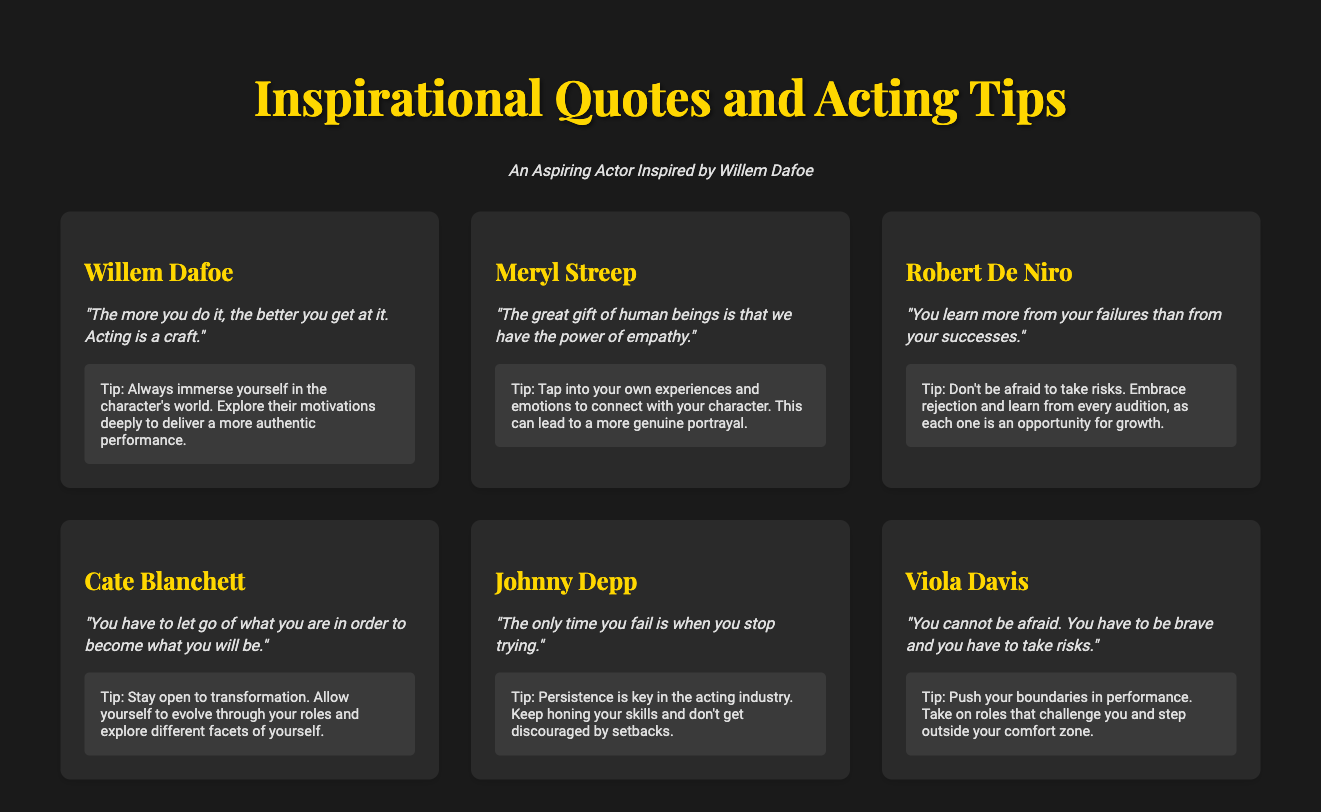What quote did Willem Dafoe say about acting? The quote by Willem Dafoe emphasizes the importance of practice in acting, specifically about doing it more to improve.
Answer: "The more you do it, the better you get at it. Acting is a craft." What is Meryl Streep's quote about human beings? Meryl Streep's quote reflects on the inherent ability of people to empathize, which is a crucial aspect of acting.
Answer: "The great gift of human beings is that we have the power of empathy." Which actor advises to embrace failure? Robert De Niro suggests that learning from failures is crucial for growth in acting.
Answer: Robert De Niro What is the main tip given by Viola Davis? Viola Davis encourages actors to overcome fear and take risks in their performances, which is essential for growth.
Answer: Be brave and take risks How many influential actors are quoted in the document? The document includes quotes from five notable actors, showcasing their wisdom and tips about acting.
Answer: Six What does Cate Blanchett recommend to actors regarding transformation? Cate Blanchett advises actors to embrace change, suggesting that letting go of past identities can help in acting.
Answer: Stay open to transformation What does Johnny Depp say about failure? Johnny Depp defines failure as simply stopping one's efforts, emphasizing the importance of persistence in acting.
Answer: "The only time you fail is when you stop trying." 